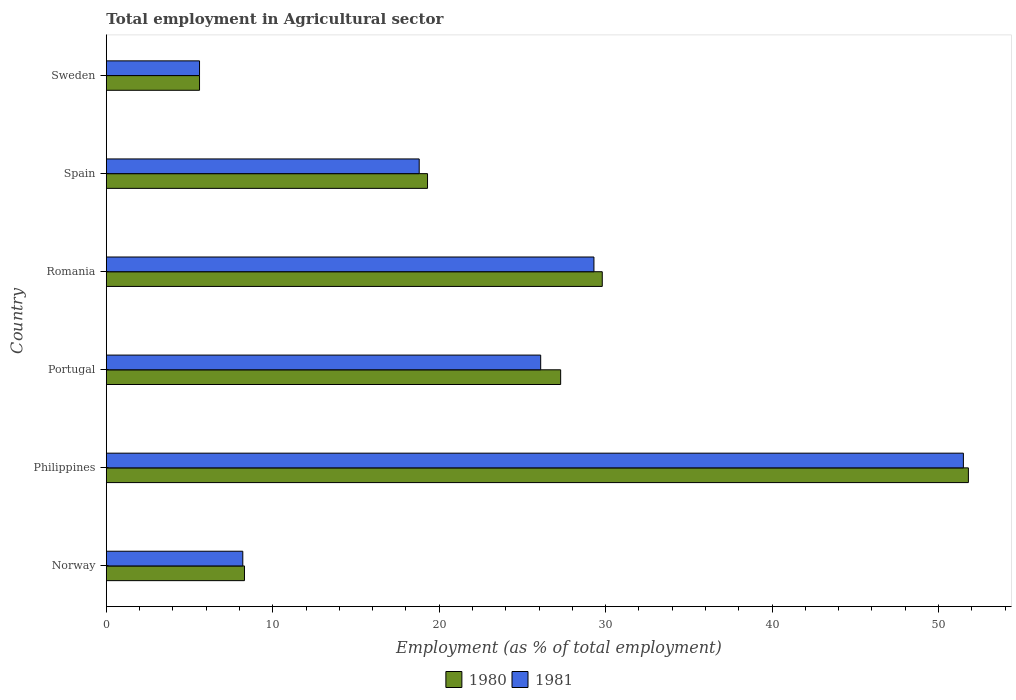How many groups of bars are there?
Give a very brief answer. 6. Are the number of bars on each tick of the Y-axis equal?
Ensure brevity in your answer.  Yes. In how many cases, is the number of bars for a given country not equal to the number of legend labels?
Your response must be concise. 0. What is the employment in agricultural sector in 1981 in Norway?
Provide a succinct answer. 8.2. Across all countries, what is the maximum employment in agricultural sector in 1981?
Give a very brief answer. 51.5. Across all countries, what is the minimum employment in agricultural sector in 1981?
Provide a succinct answer. 5.6. In which country was the employment in agricultural sector in 1981 minimum?
Your answer should be compact. Sweden. What is the total employment in agricultural sector in 1981 in the graph?
Offer a terse response. 139.5. What is the difference between the employment in agricultural sector in 1981 in Philippines and that in Spain?
Offer a very short reply. 32.7. What is the difference between the employment in agricultural sector in 1981 in Spain and the employment in agricultural sector in 1980 in Romania?
Give a very brief answer. -11. What is the average employment in agricultural sector in 1980 per country?
Your response must be concise. 23.68. What is the difference between the employment in agricultural sector in 1980 and employment in agricultural sector in 1981 in Romania?
Provide a short and direct response. 0.5. In how many countries, is the employment in agricultural sector in 1980 greater than 34 %?
Provide a short and direct response. 1. What is the ratio of the employment in agricultural sector in 1980 in Philippines to that in Portugal?
Give a very brief answer. 1.9. Is the employment in agricultural sector in 1981 in Portugal less than that in Sweden?
Make the answer very short. No. What is the difference between the highest and the second highest employment in agricultural sector in 1980?
Provide a short and direct response. 22. What is the difference between the highest and the lowest employment in agricultural sector in 1980?
Make the answer very short. 46.2. Is the sum of the employment in agricultural sector in 1981 in Philippines and Romania greater than the maximum employment in agricultural sector in 1980 across all countries?
Keep it short and to the point. Yes. Are all the bars in the graph horizontal?
Offer a very short reply. Yes. How many countries are there in the graph?
Offer a very short reply. 6. Where does the legend appear in the graph?
Ensure brevity in your answer.  Bottom center. How many legend labels are there?
Ensure brevity in your answer.  2. What is the title of the graph?
Your answer should be very brief. Total employment in Agricultural sector. Does "1992" appear as one of the legend labels in the graph?
Your response must be concise. No. What is the label or title of the X-axis?
Your answer should be compact. Employment (as % of total employment). What is the label or title of the Y-axis?
Provide a succinct answer. Country. What is the Employment (as % of total employment) of 1980 in Norway?
Ensure brevity in your answer.  8.3. What is the Employment (as % of total employment) in 1981 in Norway?
Your answer should be compact. 8.2. What is the Employment (as % of total employment) in 1980 in Philippines?
Make the answer very short. 51.8. What is the Employment (as % of total employment) of 1981 in Philippines?
Offer a very short reply. 51.5. What is the Employment (as % of total employment) of 1980 in Portugal?
Give a very brief answer. 27.3. What is the Employment (as % of total employment) of 1981 in Portugal?
Make the answer very short. 26.1. What is the Employment (as % of total employment) of 1980 in Romania?
Provide a succinct answer. 29.8. What is the Employment (as % of total employment) of 1981 in Romania?
Keep it short and to the point. 29.3. What is the Employment (as % of total employment) in 1980 in Spain?
Give a very brief answer. 19.3. What is the Employment (as % of total employment) in 1981 in Spain?
Keep it short and to the point. 18.8. What is the Employment (as % of total employment) of 1980 in Sweden?
Make the answer very short. 5.6. What is the Employment (as % of total employment) of 1981 in Sweden?
Make the answer very short. 5.6. Across all countries, what is the maximum Employment (as % of total employment) in 1980?
Your answer should be very brief. 51.8. Across all countries, what is the maximum Employment (as % of total employment) in 1981?
Keep it short and to the point. 51.5. Across all countries, what is the minimum Employment (as % of total employment) in 1980?
Your answer should be very brief. 5.6. Across all countries, what is the minimum Employment (as % of total employment) in 1981?
Offer a terse response. 5.6. What is the total Employment (as % of total employment) of 1980 in the graph?
Offer a terse response. 142.1. What is the total Employment (as % of total employment) of 1981 in the graph?
Your answer should be compact. 139.5. What is the difference between the Employment (as % of total employment) in 1980 in Norway and that in Philippines?
Make the answer very short. -43.5. What is the difference between the Employment (as % of total employment) of 1981 in Norway and that in Philippines?
Provide a succinct answer. -43.3. What is the difference between the Employment (as % of total employment) of 1980 in Norway and that in Portugal?
Make the answer very short. -19. What is the difference between the Employment (as % of total employment) of 1981 in Norway and that in Portugal?
Give a very brief answer. -17.9. What is the difference between the Employment (as % of total employment) of 1980 in Norway and that in Romania?
Your answer should be compact. -21.5. What is the difference between the Employment (as % of total employment) of 1981 in Norway and that in Romania?
Make the answer very short. -21.1. What is the difference between the Employment (as % of total employment) in 1980 in Norway and that in Spain?
Provide a succinct answer. -11. What is the difference between the Employment (as % of total employment) in 1980 in Norway and that in Sweden?
Ensure brevity in your answer.  2.7. What is the difference between the Employment (as % of total employment) in 1980 in Philippines and that in Portugal?
Offer a terse response. 24.5. What is the difference between the Employment (as % of total employment) in 1981 in Philippines and that in Portugal?
Make the answer very short. 25.4. What is the difference between the Employment (as % of total employment) in 1980 in Philippines and that in Romania?
Provide a short and direct response. 22. What is the difference between the Employment (as % of total employment) of 1981 in Philippines and that in Romania?
Provide a short and direct response. 22.2. What is the difference between the Employment (as % of total employment) in 1980 in Philippines and that in Spain?
Offer a very short reply. 32.5. What is the difference between the Employment (as % of total employment) in 1981 in Philippines and that in Spain?
Your response must be concise. 32.7. What is the difference between the Employment (as % of total employment) of 1980 in Philippines and that in Sweden?
Offer a terse response. 46.2. What is the difference between the Employment (as % of total employment) in 1981 in Philippines and that in Sweden?
Provide a succinct answer. 45.9. What is the difference between the Employment (as % of total employment) in 1980 in Portugal and that in Romania?
Offer a very short reply. -2.5. What is the difference between the Employment (as % of total employment) of 1980 in Portugal and that in Sweden?
Provide a short and direct response. 21.7. What is the difference between the Employment (as % of total employment) in 1981 in Romania and that in Spain?
Offer a terse response. 10.5. What is the difference between the Employment (as % of total employment) of 1980 in Romania and that in Sweden?
Provide a succinct answer. 24.2. What is the difference between the Employment (as % of total employment) of 1981 in Romania and that in Sweden?
Keep it short and to the point. 23.7. What is the difference between the Employment (as % of total employment) of 1980 in Norway and the Employment (as % of total employment) of 1981 in Philippines?
Your answer should be very brief. -43.2. What is the difference between the Employment (as % of total employment) of 1980 in Norway and the Employment (as % of total employment) of 1981 in Portugal?
Ensure brevity in your answer.  -17.8. What is the difference between the Employment (as % of total employment) of 1980 in Norway and the Employment (as % of total employment) of 1981 in Romania?
Give a very brief answer. -21. What is the difference between the Employment (as % of total employment) of 1980 in Norway and the Employment (as % of total employment) of 1981 in Sweden?
Provide a succinct answer. 2.7. What is the difference between the Employment (as % of total employment) in 1980 in Philippines and the Employment (as % of total employment) in 1981 in Portugal?
Provide a succinct answer. 25.7. What is the difference between the Employment (as % of total employment) in 1980 in Philippines and the Employment (as % of total employment) in 1981 in Sweden?
Provide a succinct answer. 46.2. What is the difference between the Employment (as % of total employment) of 1980 in Portugal and the Employment (as % of total employment) of 1981 in Sweden?
Your response must be concise. 21.7. What is the difference between the Employment (as % of total employment) of 1980 in Romania and the Employment (as % of total employment) of 1981 in Sweden?
Your response must be concise. 24.2. What is the average Employment (as % of total employment) of 1980 per country?
Offer a very short reply. 23.68. What is the average Employment (as % of total employment) in 1981 per country?
Make the answer very short. 23.25. What is the difference between the Employment (as % of total employment) in 1980 and Employment (as % of total employment) in 1981 in Portugal?
Your response must be concise. 1.2. What is the difference between the Employment (as % of total employment) in 1980 and Employment (as % of total employment) in 1981 in Romania?
Ensure brevity in your answer.  0.5. What is the ratio of the Employment (as % of total employment) in 1980 in Norway to that in Philippines?
Make the answer very short. 0.16. What is the ratio of the Employment (as % of total employment) in 1981 in Norway to that in Philippines?
Your answer should be compact. 0.16. What is the ratio of the Employment (as % of total employment) in 1980 in Norway to that in Portugal?
Your answer should be very brief. 0.3. What is the ratio of the Employment (as % of total employment) of 1981 in Norway to that in Portugal?
Provide a short and direct response. 0.31. What is the ratio of the Employment (as % of total employment) of 1980 in Norway to that in Romania?
Offer a terse response. 0.28. What is the ratio of the Employment (as % of total employment) in 1981 in Norway to that in Romania?
Provide a succinct answer. 0.28. What is the ratio of the Employment (as % of total employment) in 1980 in Norway to that in Spain?
Keep it short and to the point. 0.43. What is the ratio of the Employment (as % of total employment) in 1981 in Norway to that in Spain?
Ensure brevity in your answer.  0.44. What is the ratio of the Employment (as % of total employment) of 1980 in Norway to that in Sweden?
Give a very brief answer. 1.48. What is the ratio of the Employment (as % of total employment) of 1981 in Norway to that in Sweden?
Make the answer very short. 1.46. What is the ratio of the Employment (as % of total employment) of 1980 in Philippines to that in Portugal?
Make the answer very short. 1.9. What is the ratio of the Employment (as % of total employment) of 1981 in Philippines to that in Portugal?
Your answer should be very brief. 1.97. What is the ratio of the Employment (as % of total employment) of 1980 in Philippines to that in Romania?
Keep it short and to the point. 1.74. What is the ratio of the Employment (as % of total employment) in 1981 in Philippines to that in Romania?
Offer a very short reply. 1.76. What is the ratio of the Employment (as % of total employment) in 1980 in Philippines to that in Spain?
Keep it short and to the point. 2.68. What is the ratio of the Employment (as % of total employment) in 1981 in Philippines to that in Spain?
Your answer should be very brief. 2.74. What is the ratio of the Employment (as % of total employment) of 1980 in Philippines to that in Sweden?
Keep it short and to the point. 9.25. What is the ratio of the Employment (as % of total employment) of 1981 in Philippines to that in Sweden?
Ensure brevity in your answer.  9.2. What is the ratio of the Employment (as % of total employment) in 1980 in Portugal to that in Romania?
Your answer should be compact. 0.92. What is the ratio of the Employment (as % of total employment) of 1981 in Portugal to that in Romania?
Keep it short and to the point. 0.89. What is the ratio of the Employment (as % of total employment) in 1980 in Portugal to that in Spain?
Your answer should be compact. 1.41. What is the ratio of the Employment (as % of total employment) in 1981 in Portugal to that in Spain?
Your answer should be compact. 1.39. What is the ratio of the Employment (as % of total employment) of 1980 in Portugal to that in Sweden?
Offer a very short reply. 4.88. What is the ratio of the Employment (as % of total employment) in 1981 in Portugal to that in Sweden?
Provide a succinct answer. 4.66. What is the ratio of the Employment (as % of total employment) in 1980 in Romania to that in Spain?
Your answer should be very brief. 1.54. What is the ratio of the Employment (as % of total employment) of 1981 in Romania to that in Spain?
Offer a terse response. 1.56. What is the ratio of the Employment (as % of total employment) in 1980 in Romania to that in Sweden?
Your response must be concise. 5.32. What is the ratio of the Employment (as % of total employment) of 1981 in Romania to that in Sweden?
Offer a terse response. 5.23. What is the ratio of the Employment (as % of total employment) in 1980 in Spain to that in Sweden?
Your response must be concise. 3.45. What is the ratio of the Employment (as % of total employment) in 1981 in Spain to that in Sweden?
Make the answer very short. 3.36. What is the difference between the highest and the second highest Employment (as % of total employment) of 1980?
Offer a terse response. 22. What is the difference between the highest and the second highest Employment (as % of total employment) in 1981?
Your answer should be very brief. 22.2. What is the difference between the highest and the lowest Employment (as % of total employment) in 1980?
Your answer should be very brief. 46.2. What is the difference between the highest and the lowest Employment (as % of total employment) of 1981?
Ensure brevity in your answer.  45.9. 